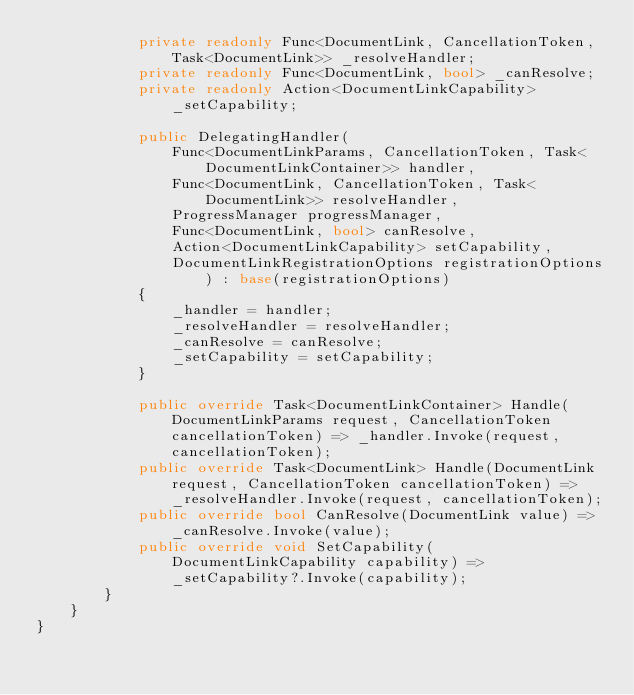Convert code to text. <code><loc_0><loc_0><loc_500><loc_500><_C#_>            private readonly Func<DocumentLink, CancellationToken, Task<DocumentLink>> _resolveHandler;
            private readonly Func<DocumentLink, bool> _canResolve;
            private readonly Action<DocumentLinkCapability> _setCapability;

            public DelegatingHandler(
                Func<DocumentLinkParams, CancellationToken, Task<DocumentLinkContainer>> handler,
                Func<DocumentLink, CancellationToken, Task<DocumentLink>> resolveHandler,
                ProgressManager progressManager,
                Func<DocumentLink, bool> canResolve,
                Action<DocumentLinkCapability> setCapability,
                DocumentLinkRegistrationOptions registrationOptions) : base(registrationOptions)
            {
                _handler = handler;
                _resolveHandler = resolveHandler;
                _canResolve = canResolve;
                _setCapability = setCapability;
            }

            public override Task<DocumentLinkContainer> Handle(DocumentLinkParams request, CancellationToken cancellationToken) => _handler.Invoke(request, cancellationToken);
            public override Task<DocumentLink> Handle(DocumentLink request, CancellationToken cancellationToken) => _resolveHandler.Invoke(request, cancellationToken);
            public override bool CanResolve(DocumentLink value) => _canResolve.Invoke(value);
            public override void SetCapability(DocumentLinkCapability capability) => _setCapability?.Invoke(capability);
        }
    }
}
</code> 